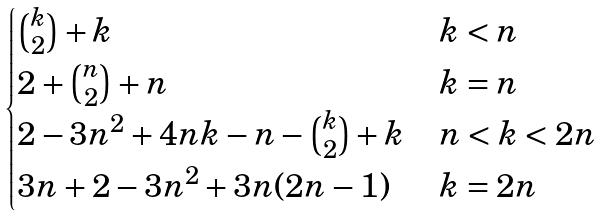<formula> <loc_0><loc_0><loc_500><loc_500>\begin{cases} \binom { k } { 2 } + k & k < n \\ 2 + \binom { n } 2 + n & k = n \\ 2 - 3 n ^ { 2 } + 4 n k - n - \binom { k } 2 + k & n < k < 2 n \\ 3 n + 2 - 3 n ^ { 2 } + 3 n ( 2 n - 1 ) & k = 2 n \\ \end{cases}</formula> 